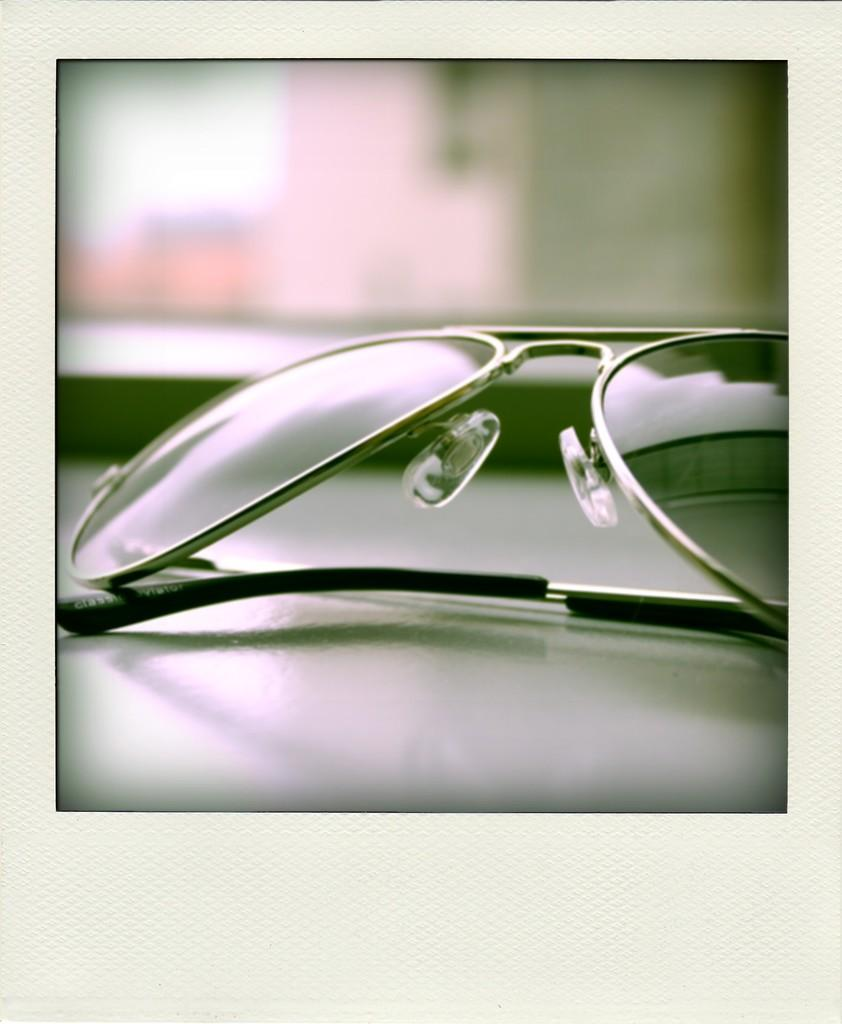What object is placed on the table in the image? There are sunglasses on the table. Can you describe the background of the image? The background of the image is blurry. What type of operation is being performed on the letter in the image? There is no letter or operation present in the image. Can you tell me how many windows are visible in the image? There are no windows visible in the image. 